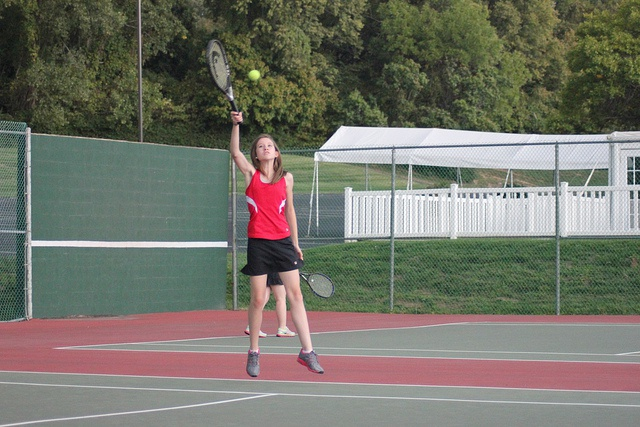Describe the objects in this image and their specific colors. I can see people in darkgreen, lightpink, black, red, and gray tones, tennis racket in darkgreen, gray, darkgray, and black tones, tennis racket in darkgreen, darkgray, and gray tones, and sports ball in darkgreen, khaki, and olive tones in this image. 